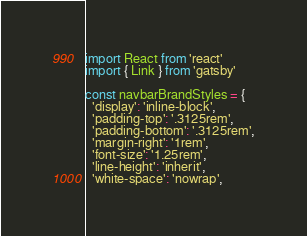<code> <loc_0><loc_0><loc_500><loc_500><_JavaScript_>import React from 'react'
import { Link } from 'gatsby'

const navbarBrandStyles = {
  'display': 'inline-block',
  'padding-top': '.3125rem',
  'padding-bottom': '.3125rem',
  'margin-right': '1rem',
  'font-size': '1.25rem',
  'line-height': 'inherit',
  'white-space': 'nowrap',</code> 